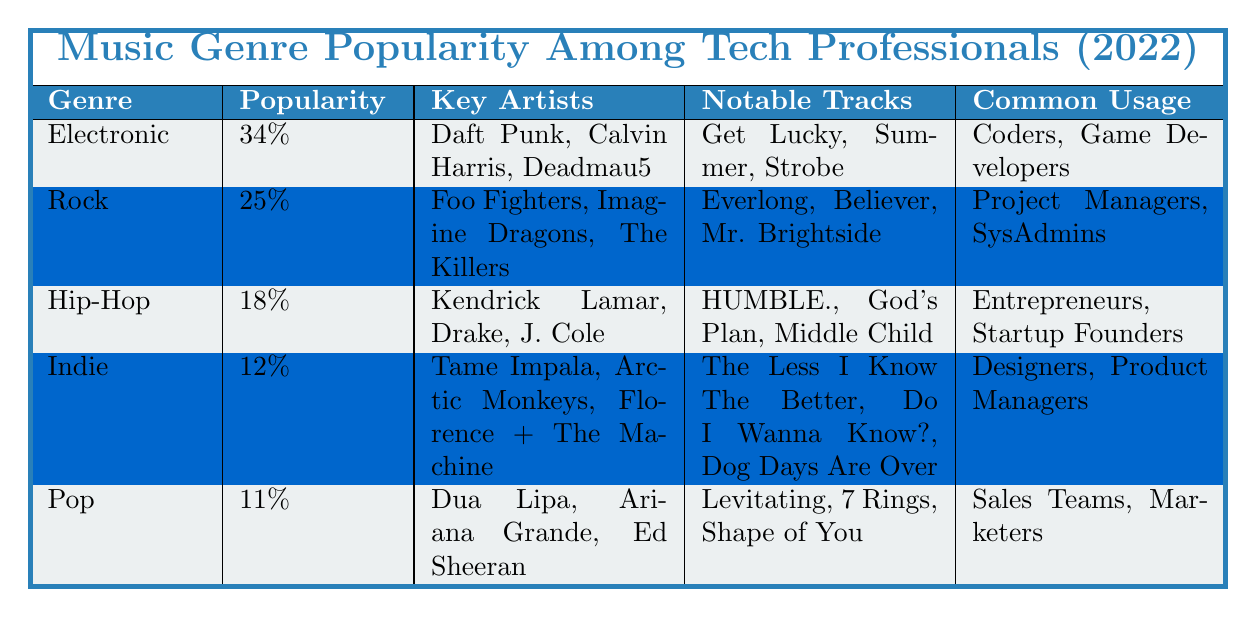What is the most popular music genre among tech professionals in 2022? The table shows that the most popular genre is Electronic, with a popularity percentage of 34%.
Answer: Electronic What percentage of tech professionals prefer Rock music? The table lists Rock with a popularity of 25%, indicating that 25% of tech professionals prefer this genre.
Answer: 25% Which genre has the least popularity among tech professionals? Indie is listed as the least popular genre with a percentage of 12%.
Answer: Indie How many genres have a popularity percentage of 20% or more? The genres with percentages of 20% or more are Electronic (34%) and Rock (25%), making a total of 2 genres.
Answer: 2 What is the percentage difference between the popularity of Electronic and Hip-Hop? The difference in popularity is calculated as 34% (Electronic) - 18% (Hip-Hop) = 16%.
Answer: 16% Are there more tech professionals who listen to Indie music compared to Pop music? The table shows Indie at 12% and Pop at 11%, so yes, more professionals listen to Indie.
Answer: Yes Which key artist is associated with the Pop genre? According to the table, key artists for Pop include Dua Lipa, Ariana Grande, and Ed Sheeran.
Answer: Dua Lipa, Ariana Grande, Ed Sheeran What are the notable tracks for the Hip-Hop genre? The notable tracks listed for Hip-Hop are HUMBLE., God's Plan, and Middle Child as per the table.
Answer: HUMBLE., God's Plan, Middle Child What is the total popularity percentage for the top three genres? Adding the percentages of the top three genres: Electronic (34%) + Rock (25%) + Hip-Hop (18%) yields a total of 77%.
Answer: 77% Which common usage group is associated with the genre Rock? The table indicates that the common usage groups for Rock are Project Managers and SysAdmins.
Answer: Project Managers, SysAdmins 